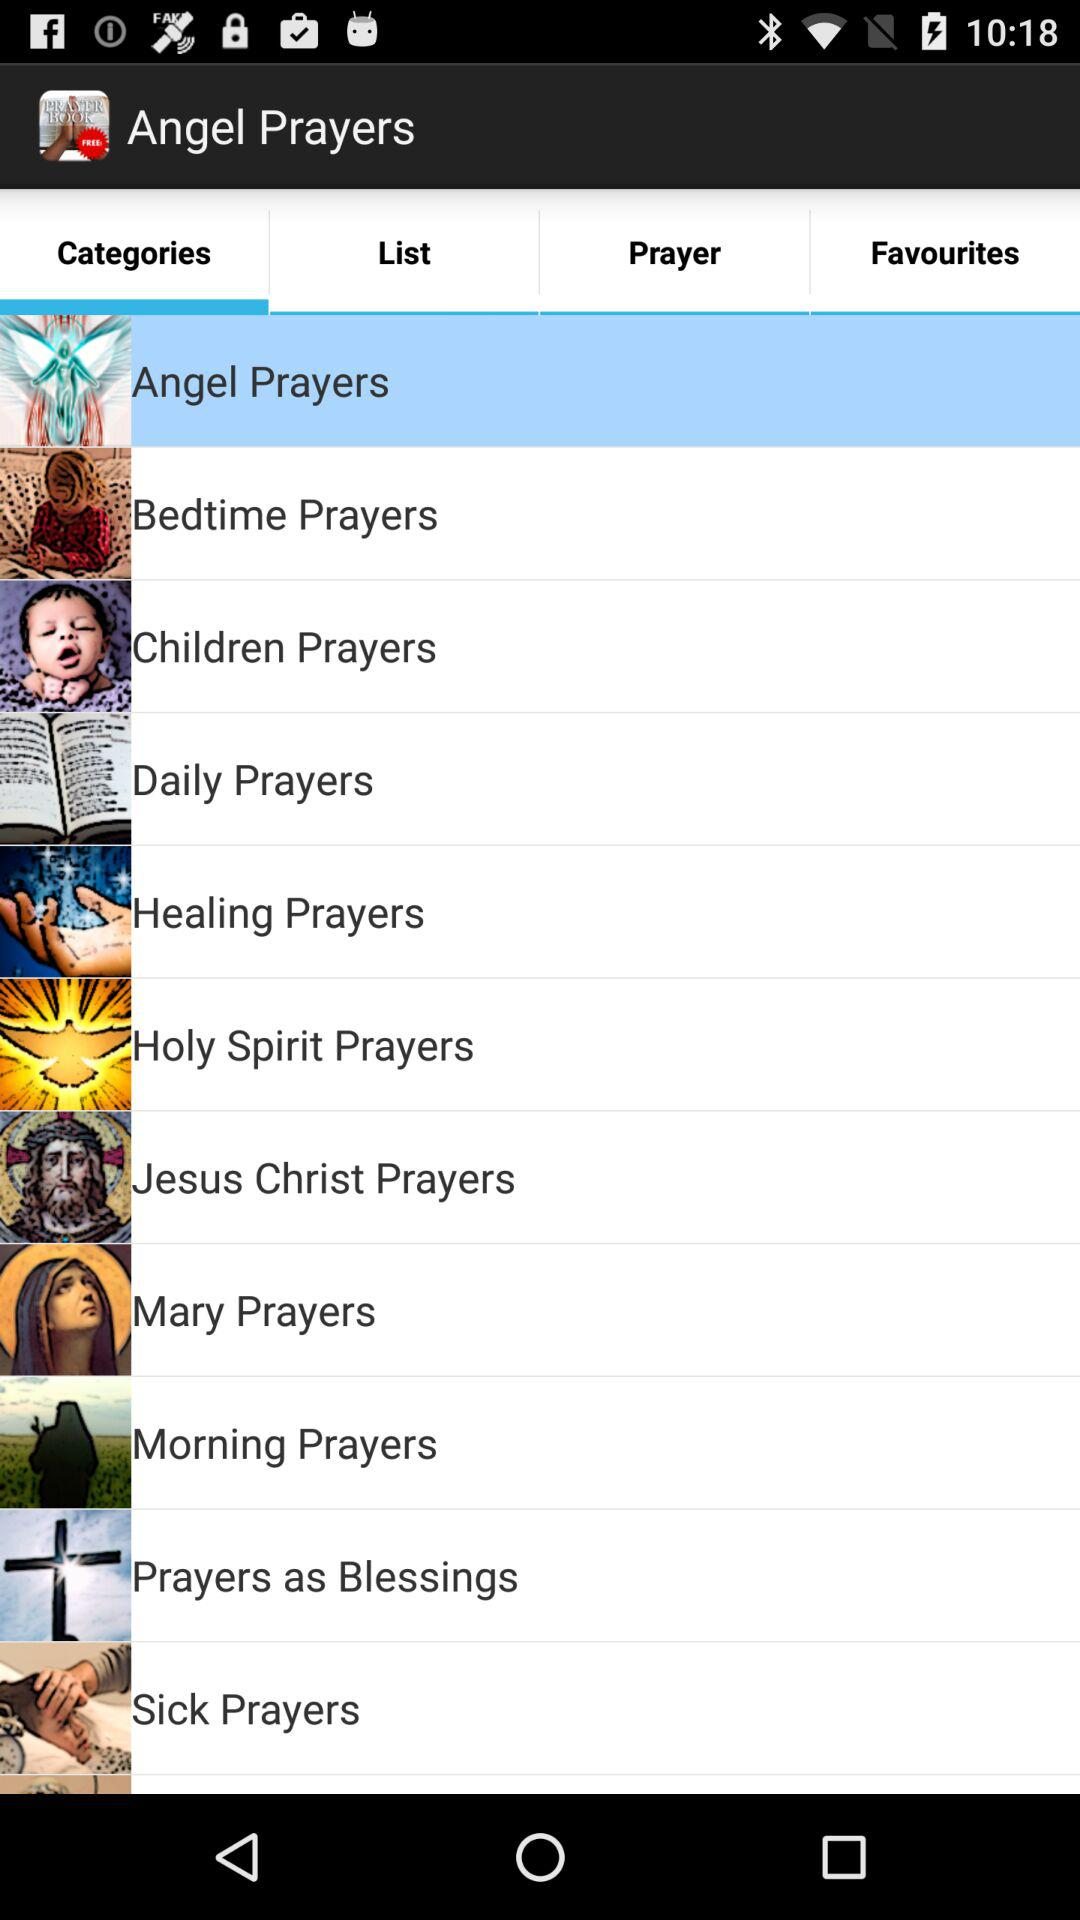Which is the selected category? The selected category is "Angel Prayers". 